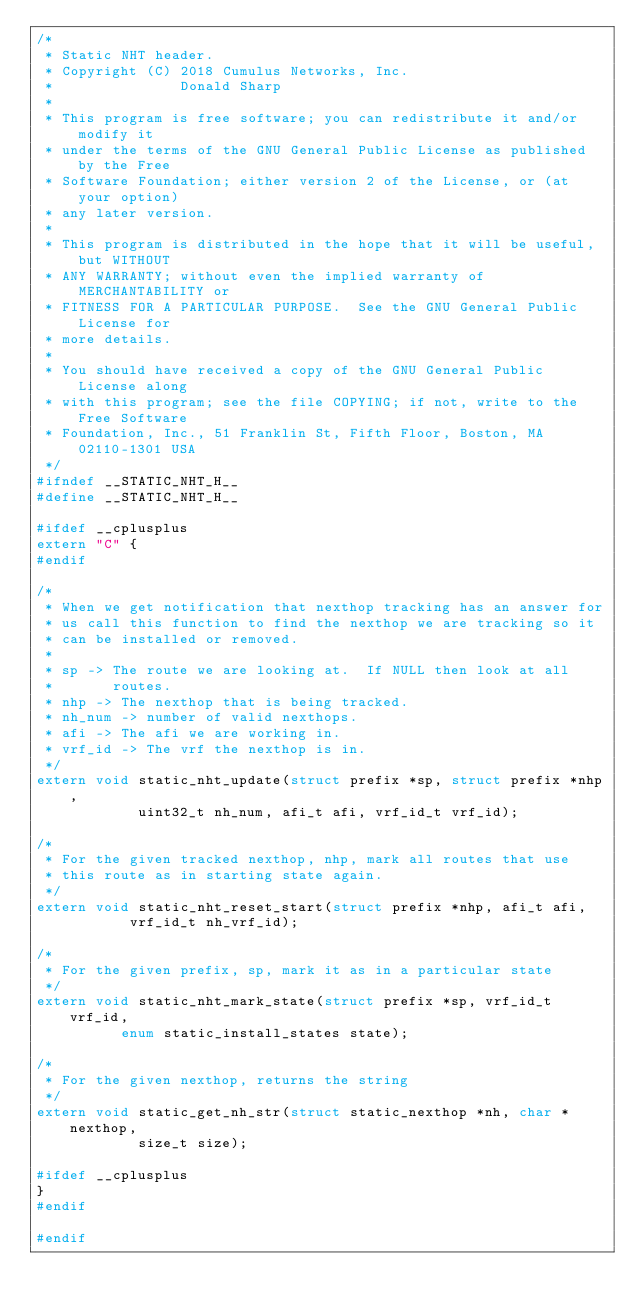Convert code to text. <code><loc_0><loc_0><loc_500><loc_500><_C_>/*
 * Static NHT header.
 * Copyright (C) 2018 Cumulus Networks, Inc.
 *               Donald Sharp
 *
 * This program is free software; you can redistribute it and/or modify it
 * under the terms of the GNU General Public License as published by the Free
 * Software Foundation; either version 2 of the License, or (at your option)
 * any later version.
 *
 * This program is distributed in the hope that it will be useful, but WITHOUT
 * ANY WARRANTY; without even the implied warranty of MERCHANTABILITY or
 * FITNESS FOR A PARTICULAR PURPOSE.  See the GNU General Public License for
 * more details.
 *
 * You should have received a copy of the GNU General Public License along
 * with this program; see the file COPYING; if not, write to the Free Software
 * Foundation, Inc., 51 Franklin St, Fifth Floor, Boston, MA 02110-1301 USA
 */
#ifndef __STATIC_NHT_H__
#define __STATIC_NHT_H__

#ifdef __cplusplus
extern "C" {
#endif

/*
 * When we get notification that nexthop tracking has an answer for
 * us call this function to find the nexthop we are tracking so it
 * can be installed or removed.
 *
 * sp -> The route we are looking at.  If NULL then look at all
 *       routes.
 * nhp -> The nexthop that is being tracked.
 * nh_num -> number of valid nexthops.
 * afi -> The afi we are working in.
 * vrf_id -> The vrf the nexthop is in.
 */
extern void static_nht_update(struct prefix *sp, struct prefix *nhp,
			      uint32_t nh_num, afi_t afi, vrf_id_t vrf_id);

/*
 * For the given tracked nexthop, nhp, mark all routes that use
 * this route as in starting state again.
 */
extern void static_nht_reset_start(struct prefix *nhp, afi_t afi,
				   vrf_id_t nh_vrf_id);

/*
 * For the given prefix, sp, mark it as in a particular state
 */
extern void static_nht_mark_state(struct prefix *sp, vrf_id_t vrf_id,
				  enum static_install_states state);

/*
 * For the given nexthop, returns the string
 */
extern void static_get_nh_str(struct static_nexthop *nh, char *nexthop,
			      size_t size);

#ifdef __cplusplus
}
#endif

#endif
</code> 